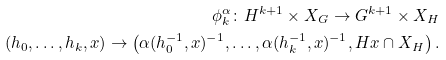Convert formula to latex. <formula><loc_0><loc_0><loc_500><loc_500>\phi ^ { \alpha } _ { k } \colon { H } ^ { k + 1 } \times X _ { G } \to { G } ^ { k + 1 } \times X _ { H } \\ ( { h } _ { 0 } , \dots , { h } _ { k } , x ) \to \left ( \alpha ( { h } _ { 0 } ^ { - 1 } , x ) ^ { - 1 } , \dots , \alpha ( { h } _ { k } ^ { - 1 } , x ) ^ { - 1 } , { H } x \cap X _ { H } \right ) .</formula> 